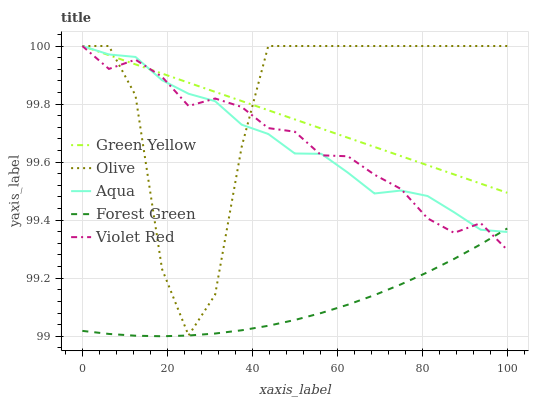Does Forest Green have the minimum area under the curve?
Answer yes or no. Yes. Does Olive have the maximum area under the curve?
Answer yes or no. Yes. Does Green Yellow have the minimum area under the curve?
Answer yes or no. No. Does Green Yellow have the maximum area under the curve?
Answer yes or no. No. Is Green Yellow the smoothest?
Answer yes or no. Yes. Is Olive the roughest?
Answer yes or no. Yes. Is Forest Green the smoothest?
Answer yes or no. No. Is Forest Green the roughest?
Answer yes or no. No. Does Forest Green have the lowest value?
Answer yes or no. Yes. Does Green Yellow have the lowest value?
Answer yes or no. No. Does Violet Red have the highest value?
Answer yes or no. Yes. Does Forest Green have the highest value?
Answer yes or no. No. Is Forest Green less than Olive?
Answer yes or no. Yes. Is Green Yellow greater than Forest Green?
Answer yes or no. Yes. Does Aqua intersect Forest Green?
Answer yes or no. Yes. Is Aqua less than Forest Green?
Answer yes or no. No. Is Aqua greater than Forest Green?
Answer yes or no. No. Does Forest Green intersect Olive?
Answer yes or no. No. 